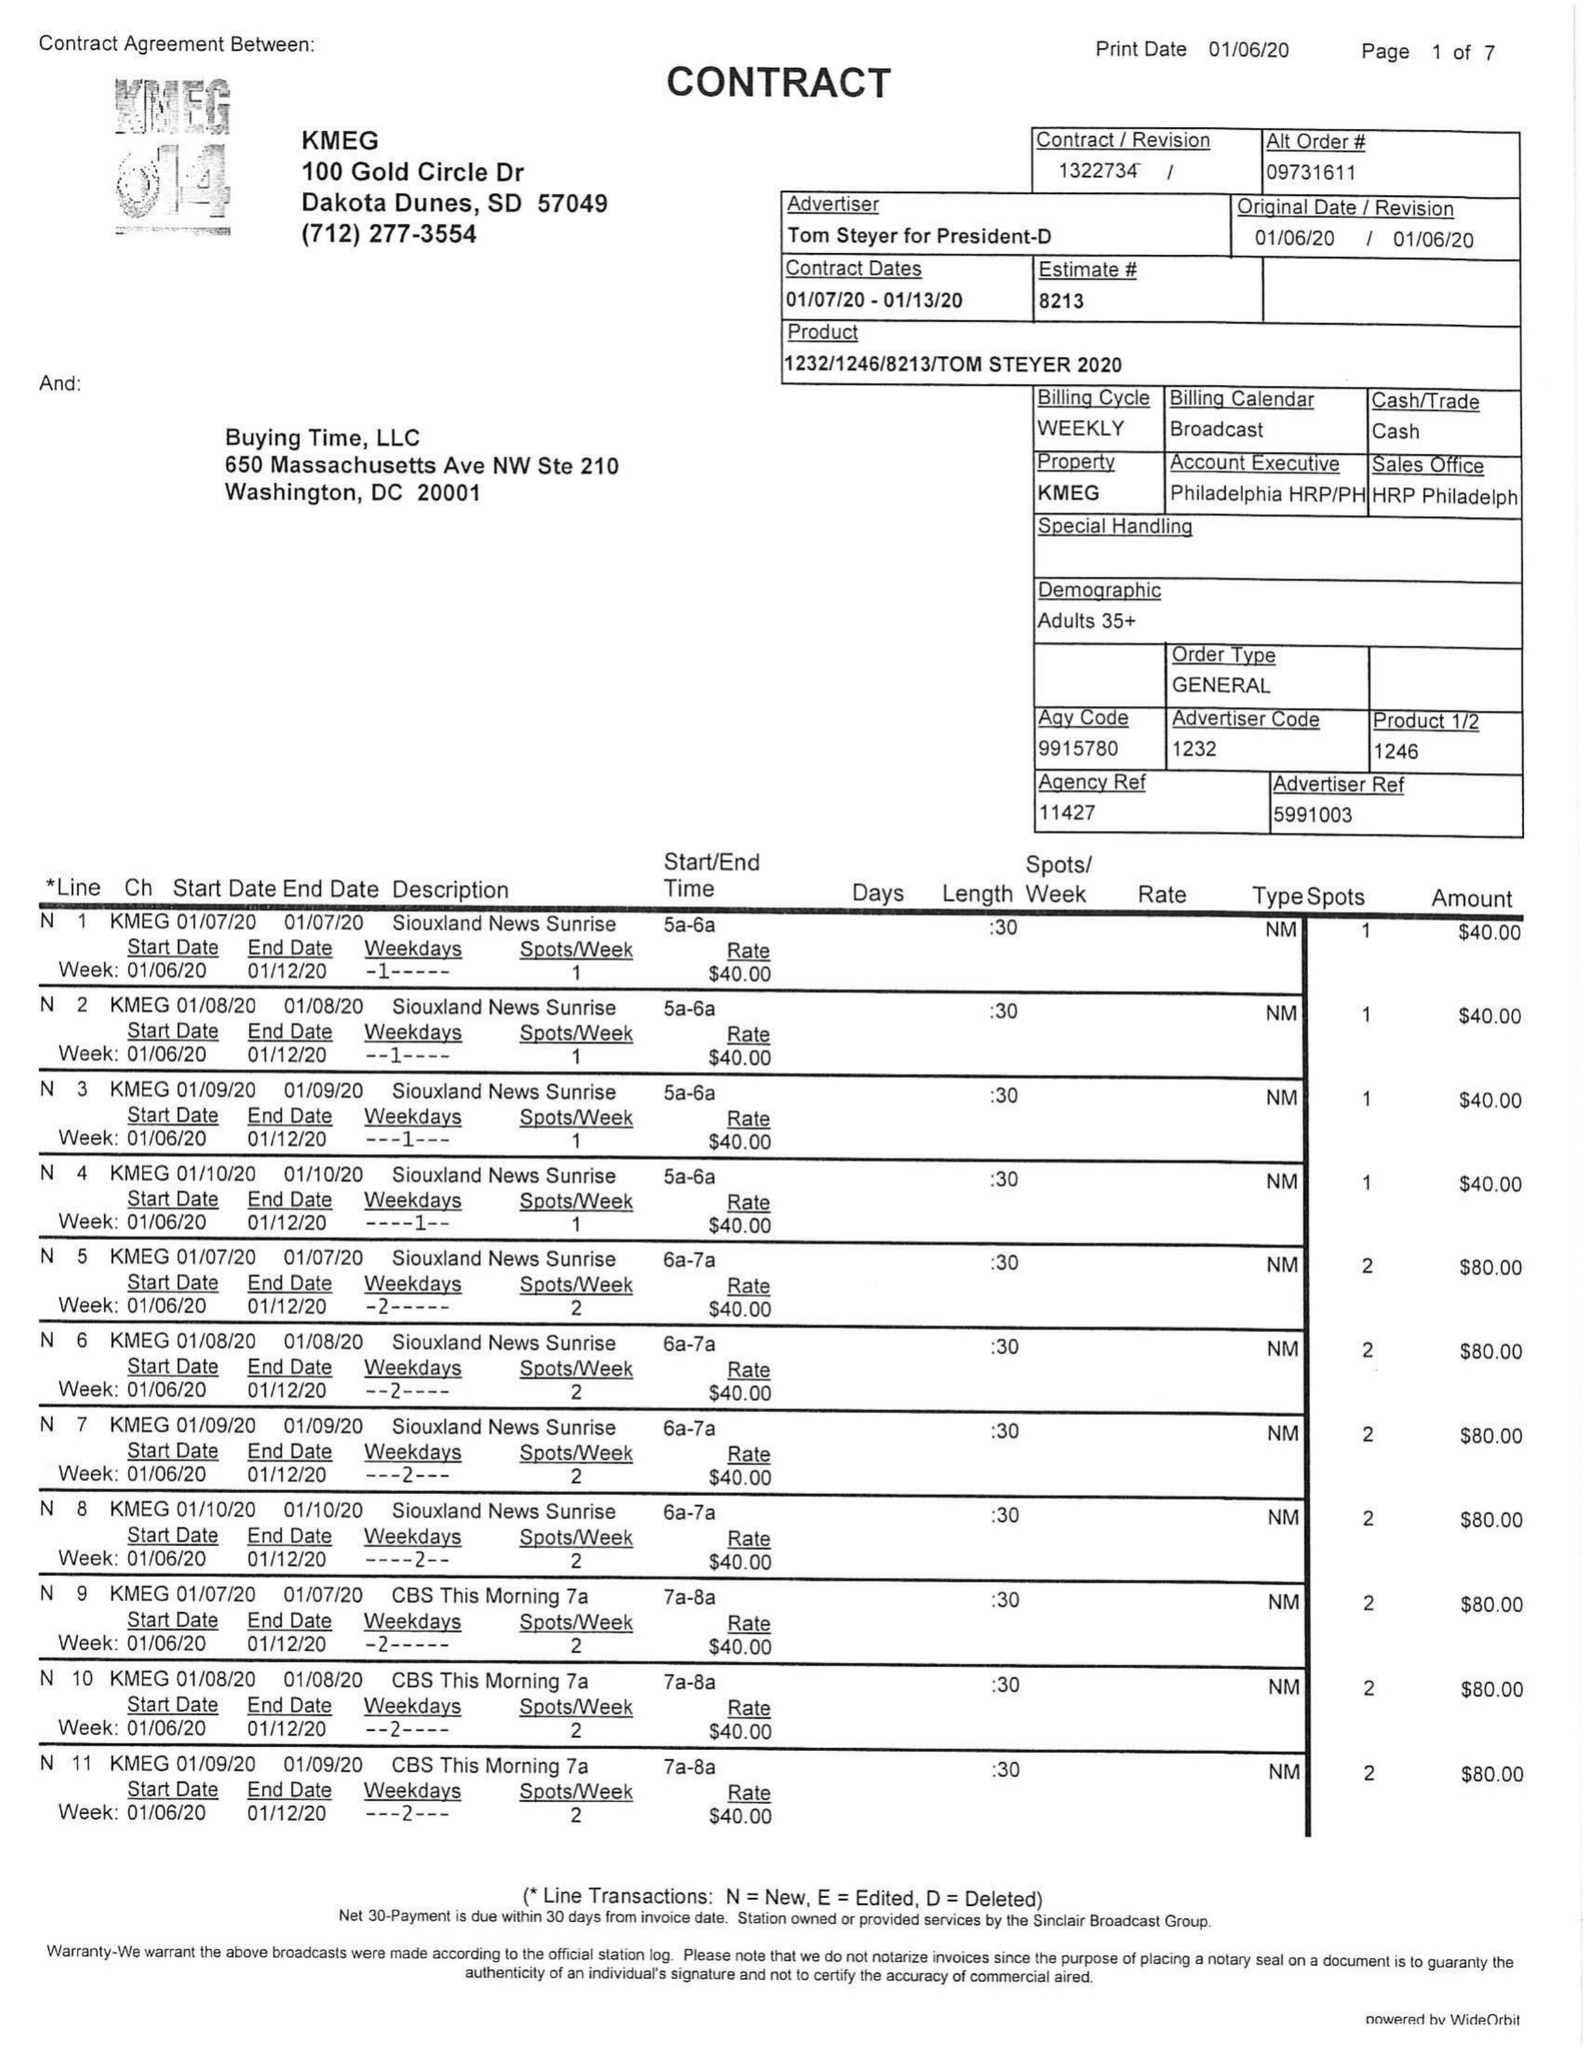What is the value for the flight_to?
Answer the question using a single word or phrase. 01/13/20 